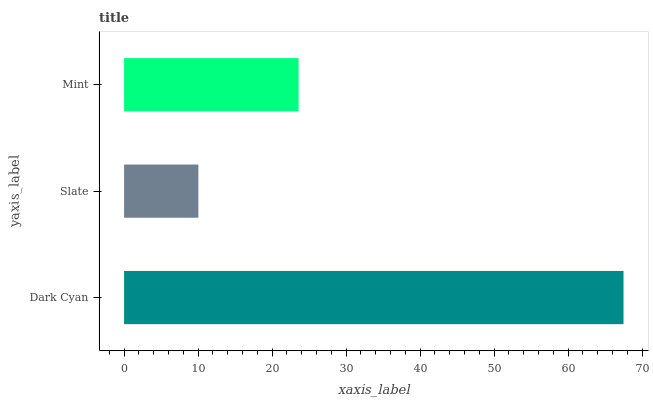Is Slate the minimum?
Answer yes or no. Yes. Is Dark Cyan the maximum?
Answer yes or no. Yes. Is Mint the minimum?
Answer yes or no. No. Is Mint the maximum?
Answer yes or no. No. Is Mint greater than Slate?
Answer yes or no. Yes. Is Slate less than Mint?
Answer yes or no. Yes. Is Slate greater than Mint?
Answer yes or no. No. Is Mint less than Slate?
Answer yes or no. No. Is Mint the high median?
Answer yes or no. Yes. Is Mint the low median?
Answer yes or no. Yes. Is Dark Cyan the high median?
Answer yes or no. No. Is Dark Cyan the low median?
Answer yes or no. No. 